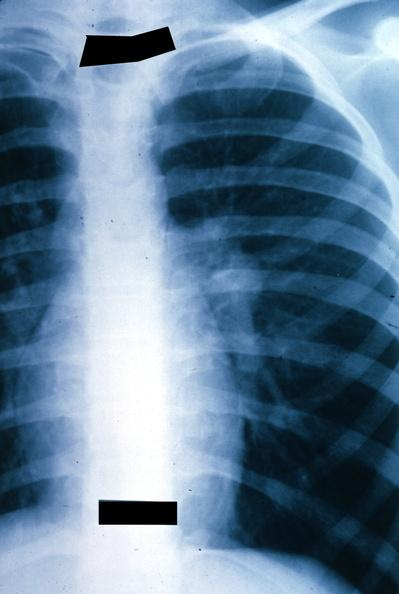how is x-ray chest left hilar tumor in hilar node?
Answer the question using a single word or phrase. Mass 